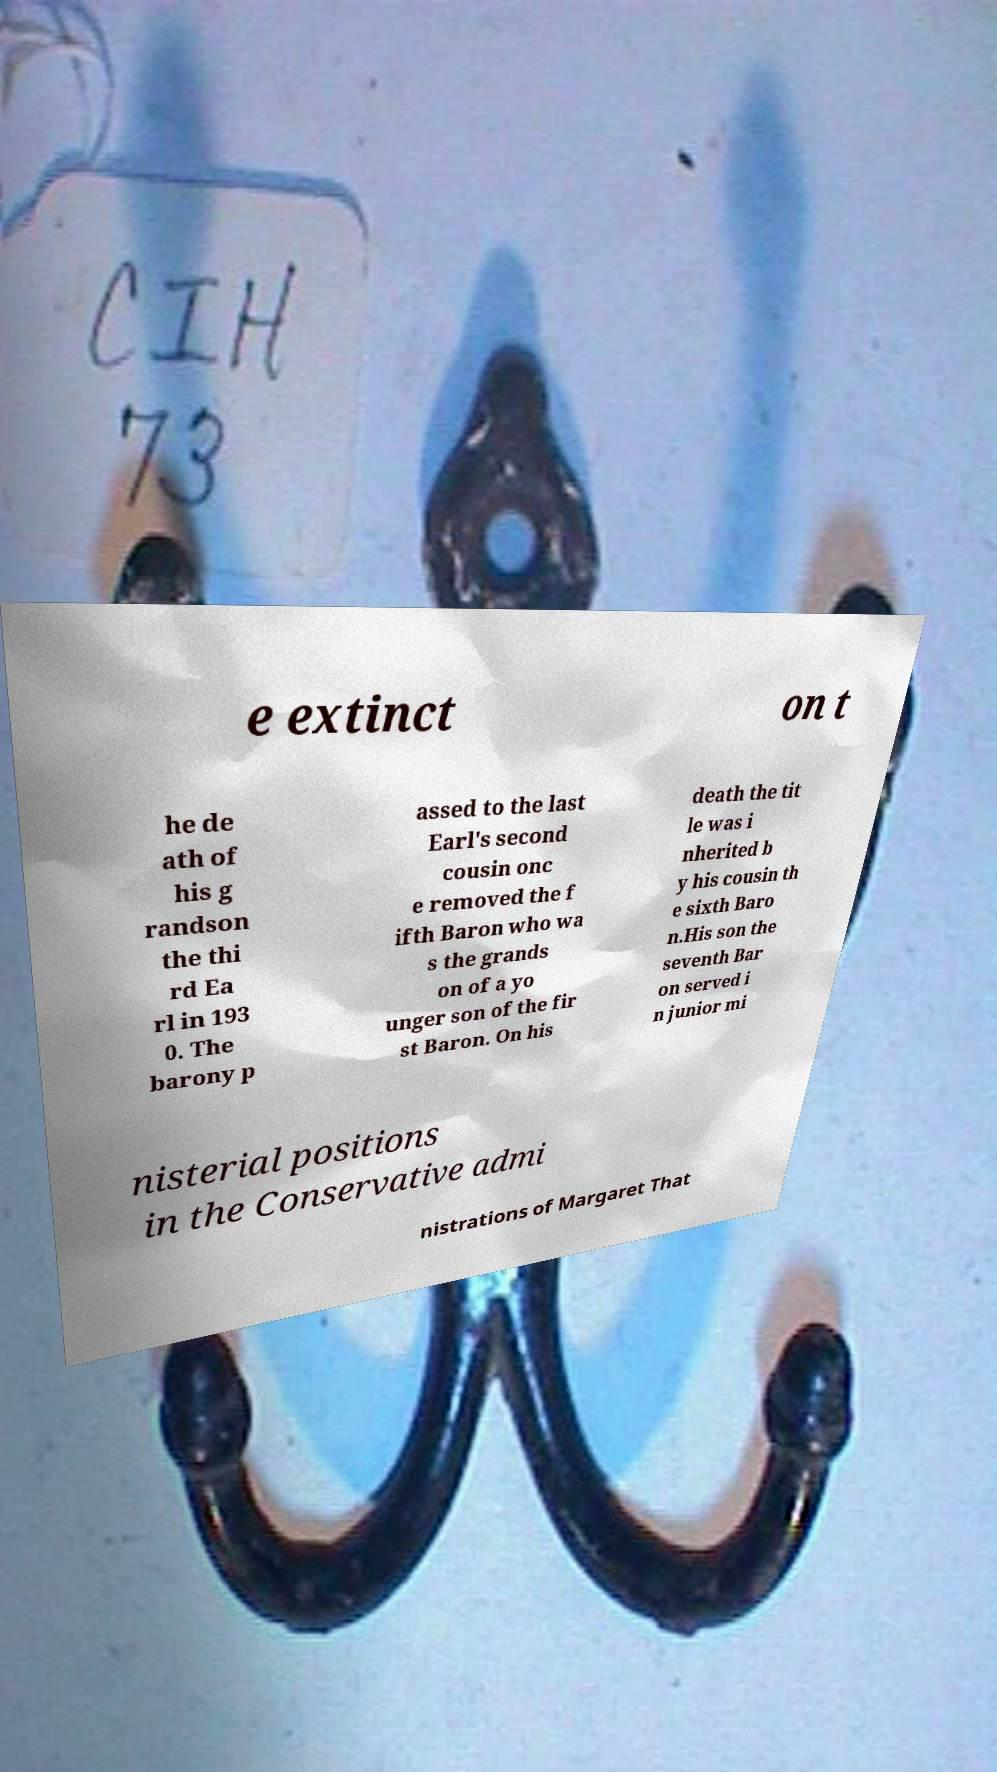Can you read and provide the text displayed in the image?This photo seems to have some interesting text. Can you extract and type it out for me? e extinct on t he de ath of his g randson the thi rd Ea rl in 193 0. The barony p assed to the last Earl's second cousin onc e removed the f ifth Baron who wa s the grands on of a yo unger son of the fir st Baron. On his death the tit le was i nherited b y his cousin th e sixth Baro n.His son the seventh Bar on served i n junior mi nisterial positions in the Conservative admi nistrations of Margaret That 